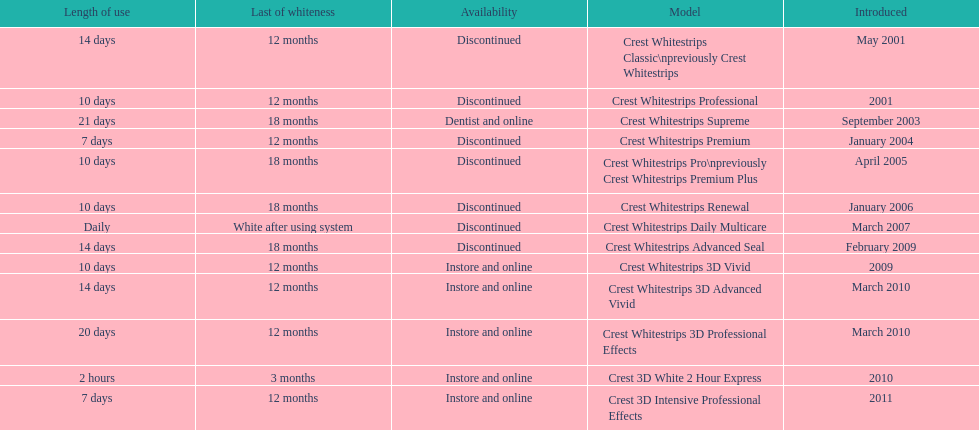Which discontinued product was introduced the same year as crest whitestrips 3d vivid? Crest Whitestrips Advanced Seal. 